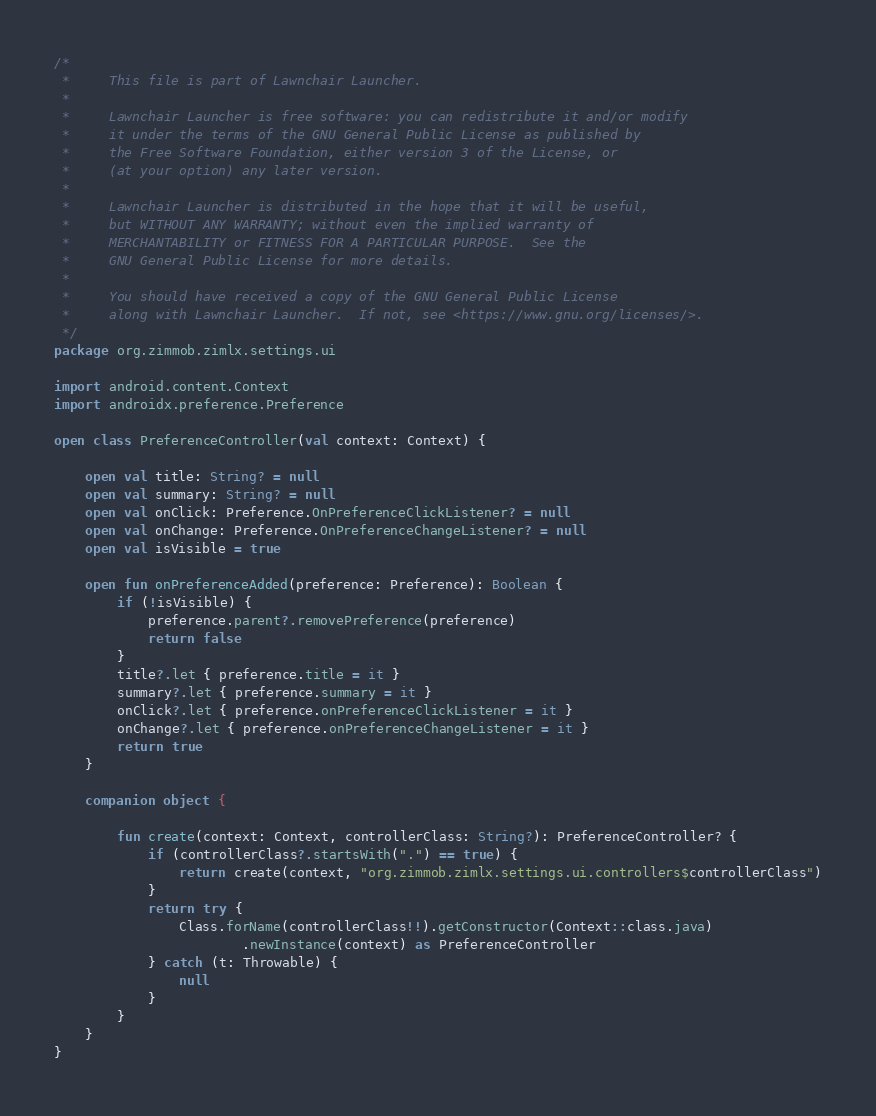<code> <loc_0><loc_0><loc_500><loc_500><_Kotlin_>/*
 *     This file is part of Lawnchair Launcher.
 *
 *     Lawnchair Launcher is free software: you can redistribute it and/or modify
 *     it under the terms of the GNU General Public License as published by
 *     the Free Software Foundation, either version 3 of the License, or
 *     (at your option) any later version.
 *
 *     Lawnchair Launcher is distributed in the hope that it will be useful,
 *     but WITHOUT ANY WARRANTY; without even the implied warranty of
 *     MERCHANTABILITY or FITNESS FOR A PARTICULAR PURPOSE.  See the
 *     GNU General Public License for more details.
 *
 *     You should have received a copy of the GNU General Public License
 *     along with Lawnchair Launcher.  If not, see <https://www.gnu.org/licenses/>.
 */
package org.zimmob.zimlx.settings.ui

import android.content.Context
import androidx.preference.Preference

open class PreferenceController(val context: Context) {

    open val title: String? = null
    open val summary: String? = null
    open val onClick: Preference.OnPreferenceClickListener? = null
    open val onChange: Preference.OnPreferenceChangeListener? = null
    open val isVisible = true

    open fun onPreferenceAdded(preference: Preference): Boolean {
        if (!isVisible) {
            preference.parent?.removePreference(preference)
            return false
        }
        title?.let { preference.title = it }
        summary?.let { preference.summary = it }
        onClick?.let { preference.onPreferenceClickListener = it }
        onChange?.let { preference.onPreferenceChangeListener = it }
        return true
    }

    companion object {

        fun create(context: Context, controllerClass: String?): PreferenceController? {
            if (controllerClass?.startsWith(".") == true) {
                return create(context, "org.zimmob.zimlx.settings.ui.controllers$controllerClass")
            }
            return try {
                Class.forName(controllerClass!!).getConstructor(Context::class.java)
                        .newInstance(context) as PreferenceController
            } catch (t: Throwable) {
                null
            }
        }
    }
}
</code> 